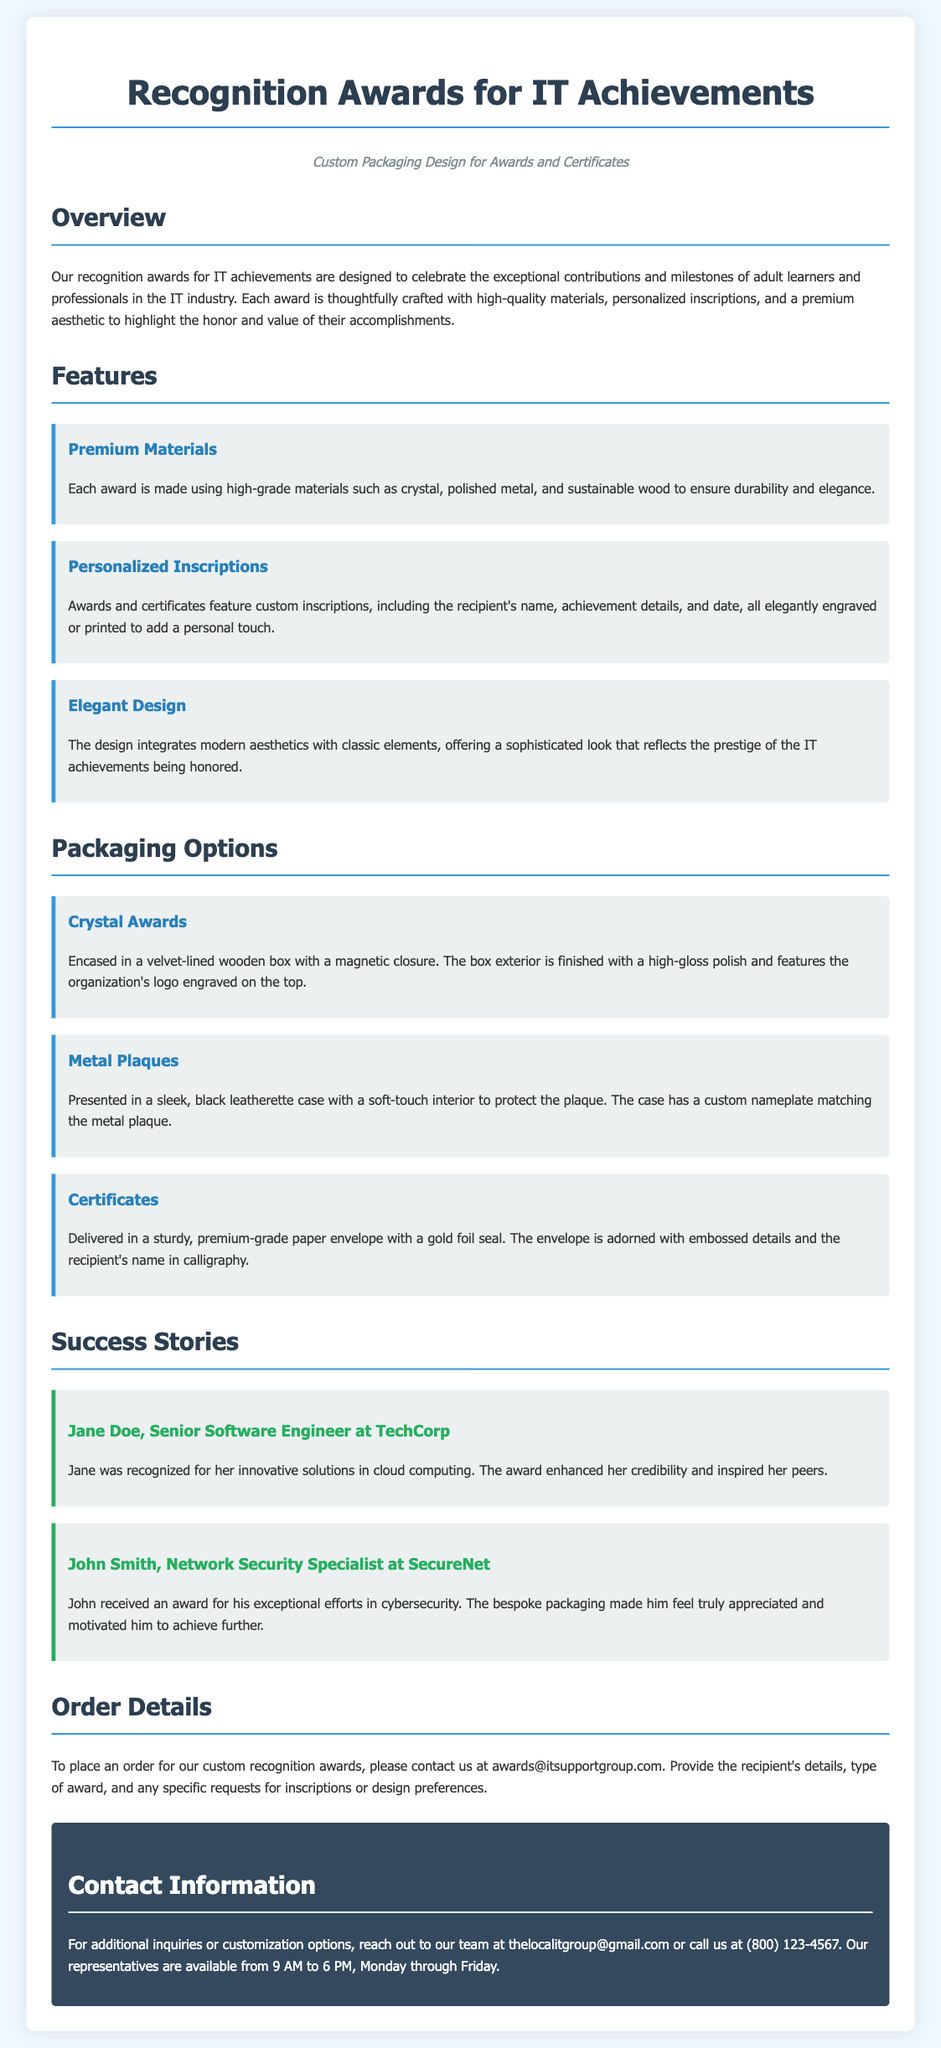What is the title of the document? The title is explicitly stated at the top of the document and indicates its main subject.
Answer: Recognition Awards for IT Achievements What materials are used for the awards? The document lists the specific high-grade materials used for the awards in the features section.
Answer: Crystal, polished metal, and sustainable wood What is the packaging option for the Crystal Awards? The packaging option details for the Crystal Awards are provided in the packaging section of the document.
Answer: Velvet-lined wooden box with magnetic closure Who was recognized for innovative solutions in cloud computing? The document provides the name of the individual recognized for this specific achievement in the success stories section.
Answer: Jane Doe What is the email address for placing an order? The document specifies a contact email for orders, located in the order details section.
Answer: awards@itsupportgroup.com How does the award's design enhance its perception? The document states how the design integrates aesthetics with classic elements to reflect prestige, requiring reasoning about design impact.
Answer: Sophisticated look What type of case is used for Metal Plaques? The details about the case type for Metal Plaques are mentioned in the packaging options section of the document.
Answer: Black leatherette case How can customization inquiries be made? The document specifies a contact method for inquiries regarding customization options at the end of the document.
Answer: Contact thelocalitgroup@gmail.com What time are representatives available for contact? The availability of representatives is clearly stated in the contact information section under specific hours.
Answer: 9 AM to 6 PM 